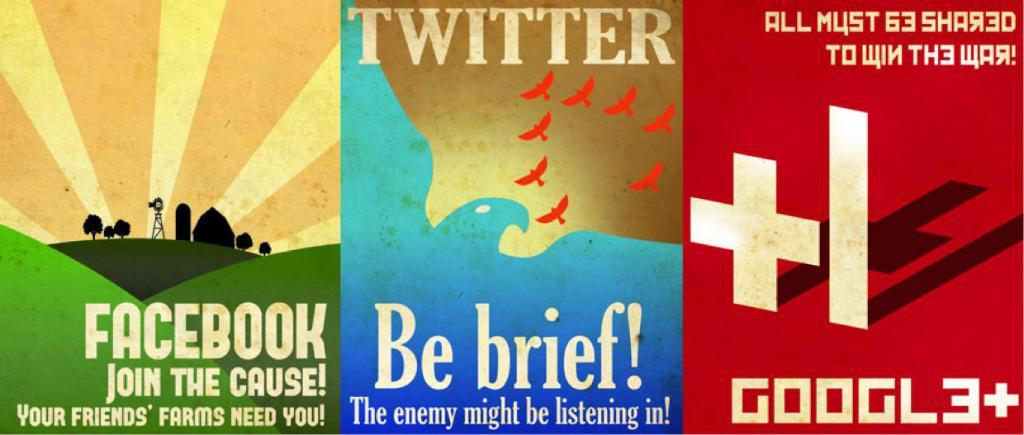Provide a one-sentence caption for the provided image. The middle poster is titled by the company Twitter. 